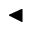<formula> <loc_0><loc_0><loc_500><loc_500>\blacktriangleleft</formula> 